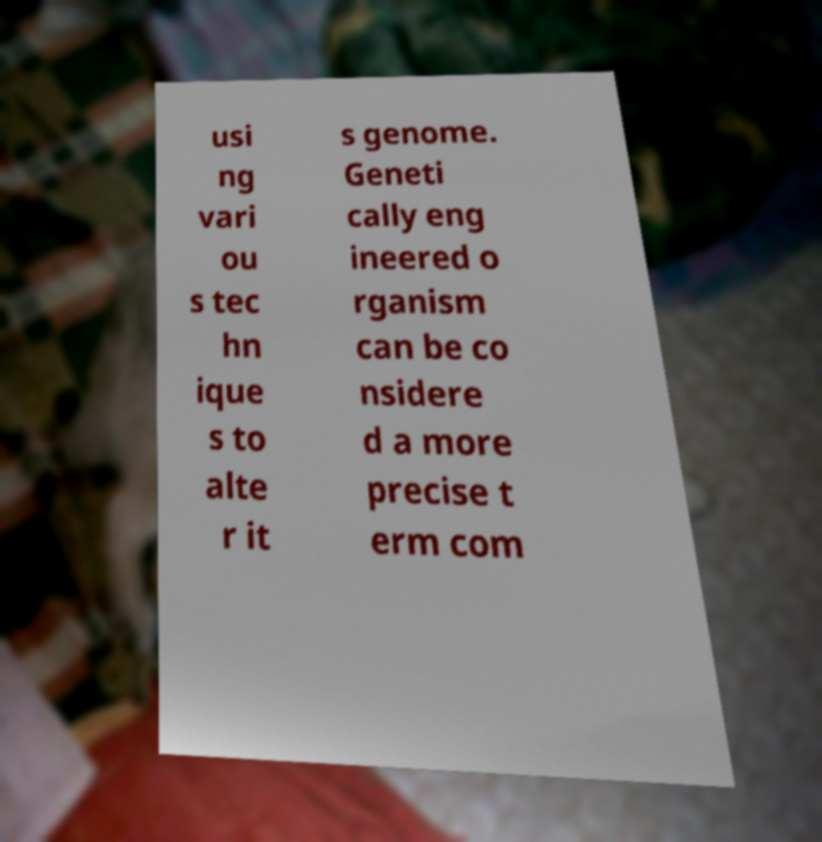Please read and relay the text visible in this image. What does it say? usi ng vari ou s tec hn ique s to alte r it s genome. Geneti cally eng ineered o rganism can be co nsidere d a more precise t erm com 